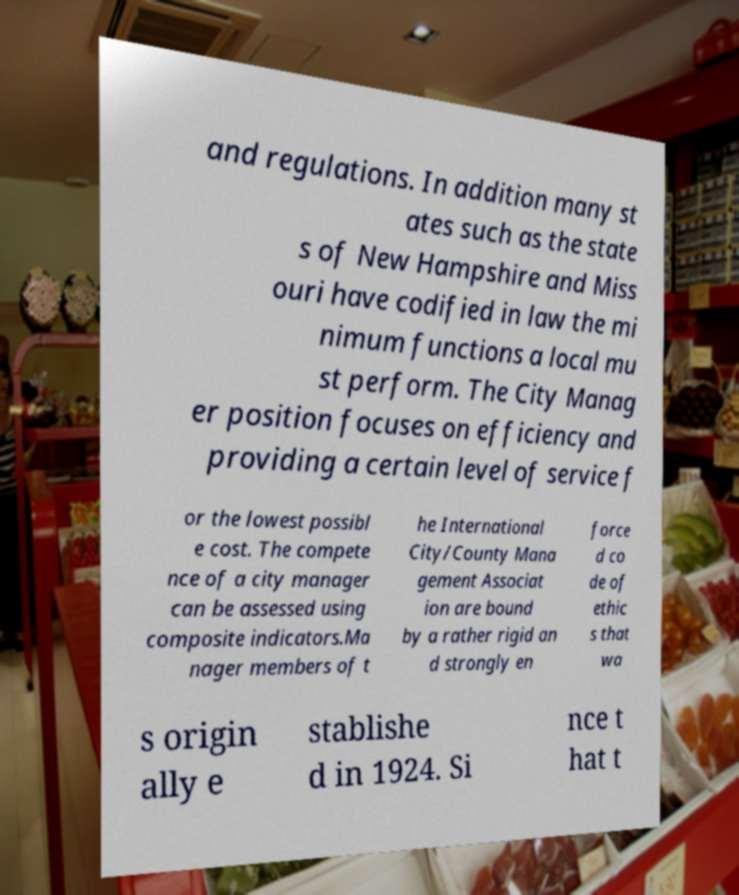Can you read and provide the text displayed in the image?This photo seems to have some interesting text. Can you extract and type it out for me? and regulations. In addition many st ates such as the state s of New Hampshire and Miss ouri have codified in law the mi nimum functions a local mu st perform. The City Manag er position focuses on efficiency and providing a certain level of service f or the lowest possibl e cost. The compete nce of a city manager can be assessed using composite indicators.Ma nager members of t he International City/County Mana gement Associat ion are bound by a rather rigid an d strongly en force d co de of ethic s that wa s origin ally e stablishe d in 1924. Si nce t hat t 